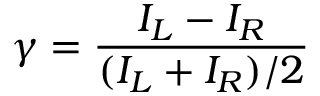<formula> <loc_0><loc_0><loc_500><loc_500>\gamma = \frac { I _ { L } - I _ { R } } { ( I _ { L } + I _ { R } ) / 2 }</formula> 